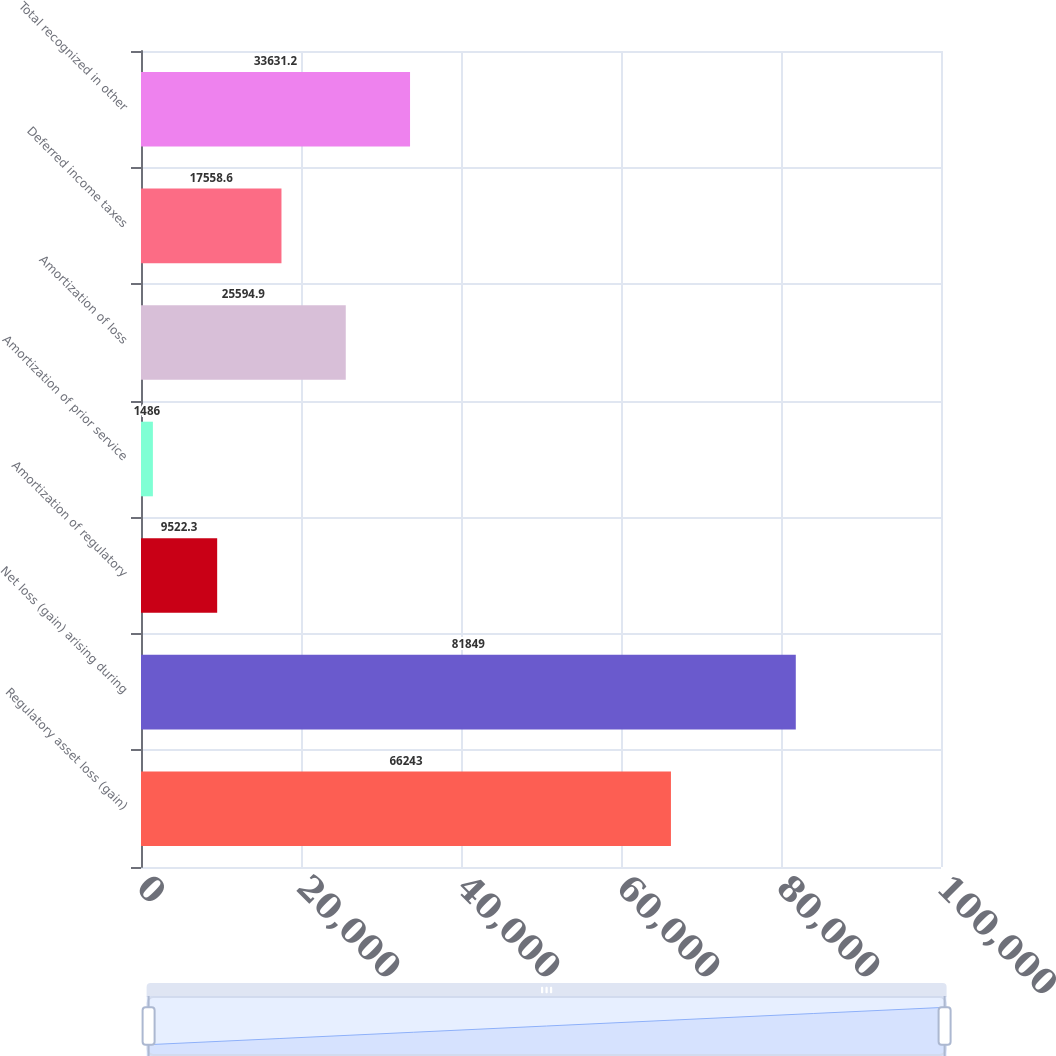Convert chart. <chart><loc_0><loc_0><loc_500><loc_500><bar_chart><fcel>Regulatory asset loss (gain)<fcel>Net loss (gain) arising during<fcel>Amortization of regulatory<fcel>Amortization of prior service<fcel>Amortization of loss<fcel>Deferred income taxes<fcel>Total recognized in other<nl><fcel>66243<fcel>81849<fcel>9522.3<fcel>1486<fcel>25594.9<fcel>17558.6<fcel>33631.2<nl></chart> 